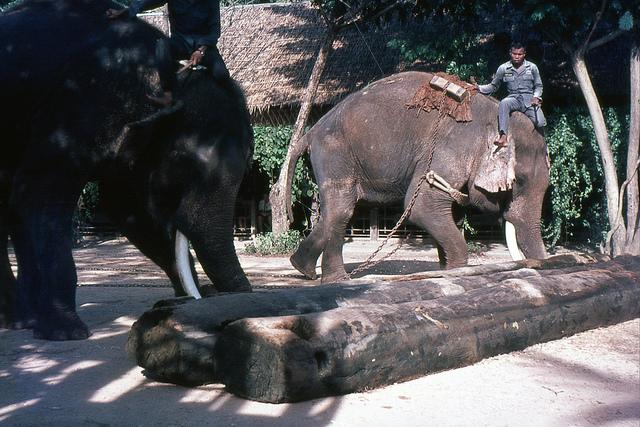Who is the man?
Write a very short answer. Trainer. How heavy is the wood?
Short answer required. Very. Are these elephants workers or pets?
Write a very short answer. Workers. Do these animals have spots?
Concise answer only. No. 